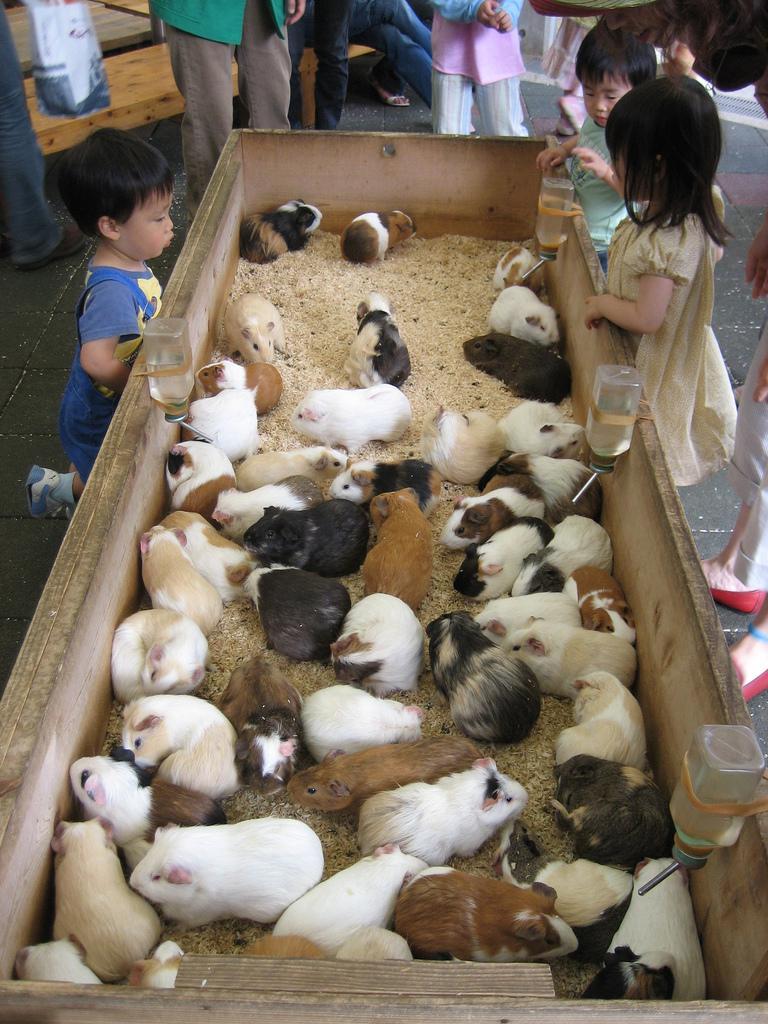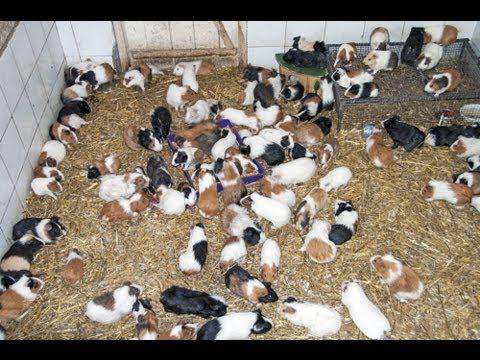The first image is the image on the left, the second image is the image on the right. Given the left and right images, does the statement "Left image contains no more than five hamsters, which are in a wood-sided enclosure." hold true? Answer yes or no. No. The first image is the image on the left, the second image is the image on the right. Examine the images to the left and right. Is the description "At least one of the pictures shows less than 10 rodents." accurate? Answer yes or no. No. 